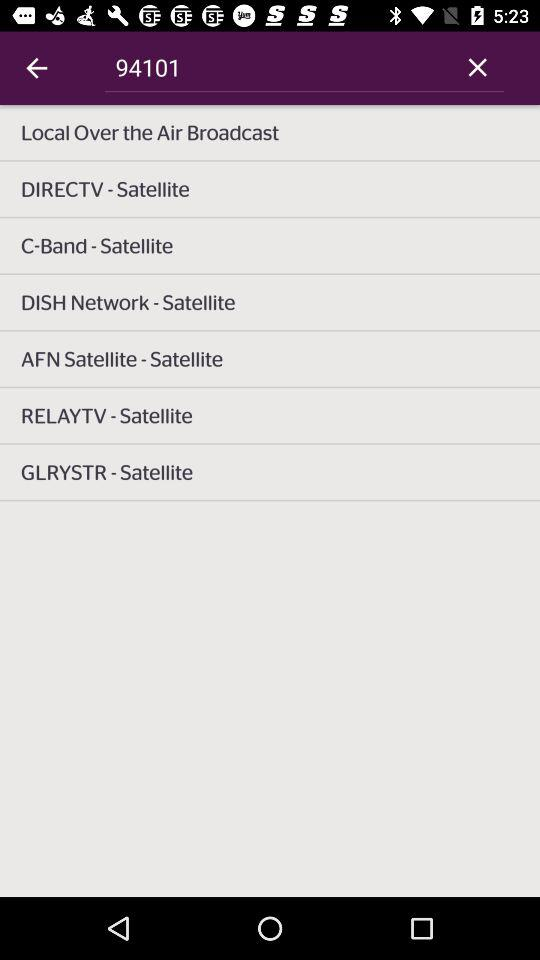What is the number in the search box? The number in the search box is 94101. 